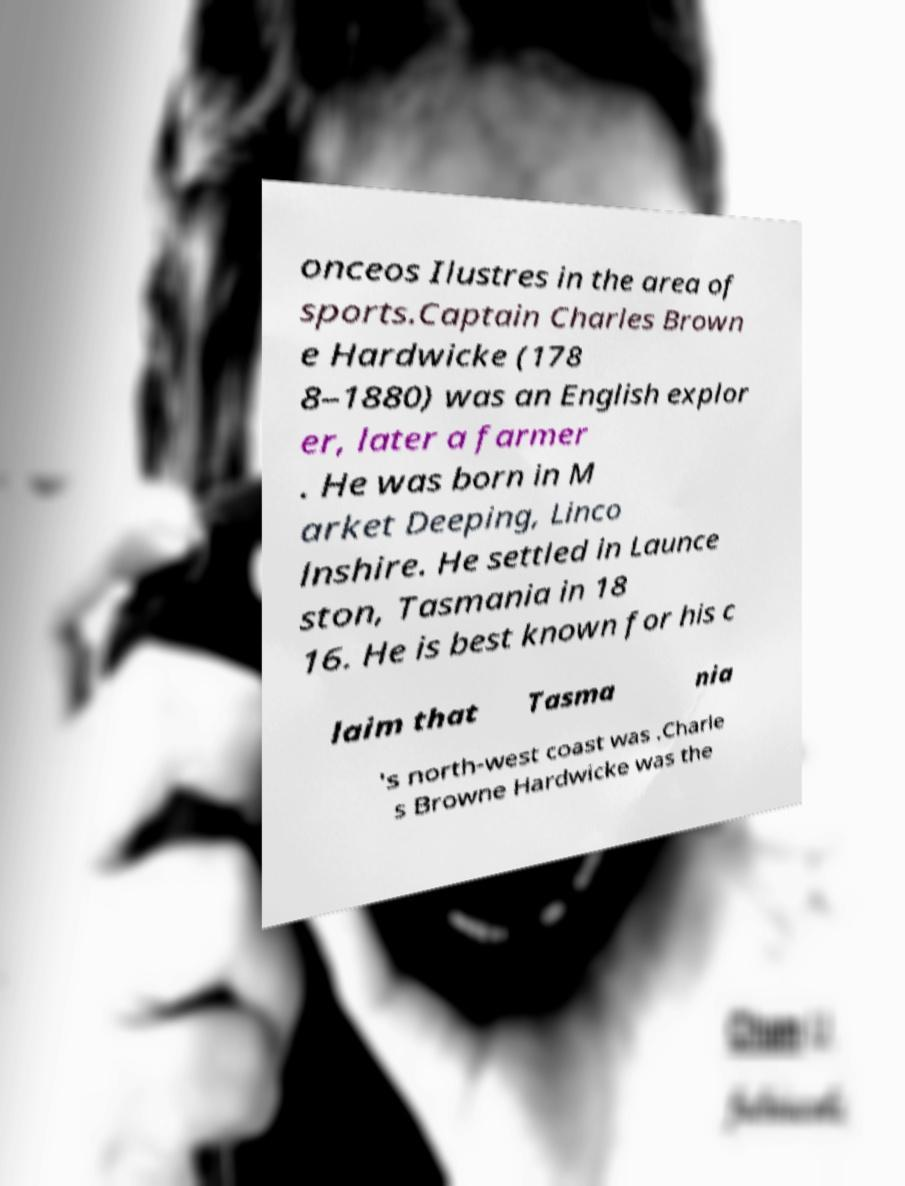Could you extract and type out the text from this image? onceos Ilustres in the area of sports.Captain Charles Brown e Hardwicke (178 8–1880) was an English explor er, later a farmer . He was born in M arket Deeping, Linco lnshire. He settled in Launce ston, Tasmania in 18 16. He is best known for his c laim that Tasma nia 's north-west coast was .Charle s Browne Hardwicke was the 